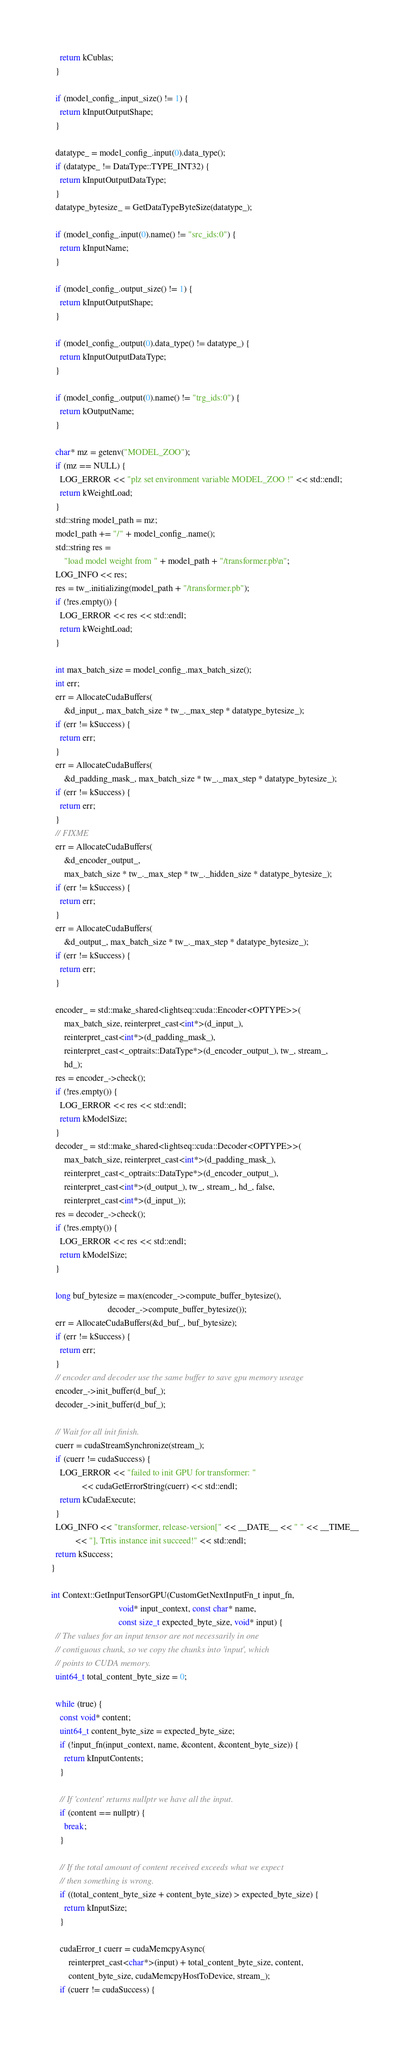<code> <loc_0><loc_0><loc_500><loc_500><_Cuda_>    return kCublas;
  }

  if (model_config_.input_size() != 1) {
    return kInputOutputShape;
  }

  datatype_ = model_config_.input(0).data_type();
  if (datatype_ != DataType::TYPE_INT32) {
    return kInputOutputDataType;
  }
  datatype_bytesize_ = GetDataTypeByteSize(datatype_);

  if (model_config_.input(0).name() != "src_ids:0") {
    return kInputName;
  }

  if (model_config_.output_size() != 1) {
    return kInputOutputShape;
  }

  if (model_config_.output(0).data_type() != datatype_) {
    return kInputOutputDataType;
  }

  if (model_config_.output(0).name() != "trg_ids:0") {
    return kOutputName;
  }

  char* mz = getenv("MODEL_ZOO");
  if (mz == NULL) {
    LOG_ERROR << "plz set environment variable MODEL_ZOO !" << std::endl;
    return kWeightLoad;
  }
  std::string model_path = mz;
  model_path += "/" + model_config_.name();
  std::string res =
      "load model weight from " + model_path + "/transformer.pb\n";
  LOG_INFO << res;
  res = tw_.initializing(model_path + "/transformer.pb");
  if (!res.empty()) {
    LOG_ERROR << res << std::endl;
    return kWeightLoad;
  }

  int max_batch_size = model_config_.max_batch_size();
  int err;
  err = AllocateCudaBuffers(
      &d_input_, max_batch_size * tw_._max_step * datatype_bytesize_);
  if (err != kSuccess) {
    return err;
  }
  err = AllocateCudaBuffers(
      &d_padding_mask_, max_batch_size * tw_._max_step * datatype_bytesize_);
  if (err != kSuccess) {
    return err;
  }
  // FIXME
  err = AllocateCudaBuffers(
      &d_encoder_output_,
      max_batch_size * tw_._max_step * tw_._hidden_size * datatype_bytesize_);
  if (err != kSuccess) {
    return err;
  }
  err = AllocateCudaBuffers(
      &d_output_, max_batch_size * tw_._max_step * datatype_bytesize_);
  if (err != kSuccess) {
    return err;
  }

  encoder_ = std::make_shared<lightseq::cuda::Encoder<OPTYPE>>(
      max_batch_size, reinterpret_cast<int*>(d_input_),
      reinterpret_cast<int*>(d_padding_mask_),
      reinterpret_cast<_optraits::DataType*>(d_encoder_output_), tw_, stream_,
      hd_);
  res = encoder_->check();
  if (!res.empty()) {
    LOG_ERROR << res << std::endl;
    return kModelSize;
  }
  decoder_ = std::make_shared<lightseq::cuda::Decoder<OPTYPE>>(
      max_batch_size, reinterpret_cast<int*>(d_padding_mask_),
      reinterpret_cast<_optraits::DataType*>(d_encoder_output_),
      reinterpret_cast<int*>(d_output_), tw_, stream_, hd_, false,
      reinterpret_cast<int*>(d_input_));
  res = decoder_->check();
  if (!res.empty()) {
    LOG_ERROR << res << std::endl;
    return kModelSize;
  }

  long buf_bytesize = max(encoder_->compute_buffer_bytesize(),
                          decoder_->compute_buffer_bytesize());
  err = AllocateCudaBuffers(&d_buf_, buf_bytesize);
  if (err != kSuccess) {
    return err;
  }
  // encoder and decoder use the same buffer to save gpu memory useage
  encoder_->init_buffer(d_buf_);
  decoder_->init_buffer(d_buf_);

  // Wait for all init finish.
  cuerr = cudaStreamSynchronize(stream_);
  if (cuerr != cudaSuccess) {
    LOG_ERROR << "failed to init GPU for transformer: "
              << cudaGetErrorString(cuerr) << std::endl;
    return kCudaExecute;
  }
  LOG_INFO << "transformer, release-version[" << __DATE__ << " " << __TIME__
           << "], Trtis instance init succeed!" << std::endl;
  return kSuccess;
}

int Context::GetInputTensorGPU(CustomGetNextInputFn_t input_fn,
                               void* input_context, const char* name,
                               const size_t expected_byte_size, void* input) {
  // The values for an input tensor are not necessarily in one
  // contiguous chunk, so we copy the chunks into 'input', which
  // points to CUDA memory.
  uint64_t total_content_byte_size = 0;

  while (true) {
    const void* content;
    uint64_t content_byte_size = expected_byte_size;
    if (!input_fn(input_context, name, &content, &content_byte_size)) {
      return kInputContents;
    }

    // If 'content' returns nullptr we have all the input.
    if (content == nullptr) {
      break;
    }

    // If the total amount of content received exceeds what we expect
    // then something is wrong.
    if ((total_content_byte_size + content_byte_size) > expected_byte_size) {
      return kInputSize;
    }

    cudaError_t cuerr = cudaMemcpyAsync(
        reinterpret_cast<char*>(input) + total_content_byte_size, content,
        content_byte_size, cudaMemcpyHostToDevice, stream_);
    if (cuerr != cudaSuccess) {</code> 